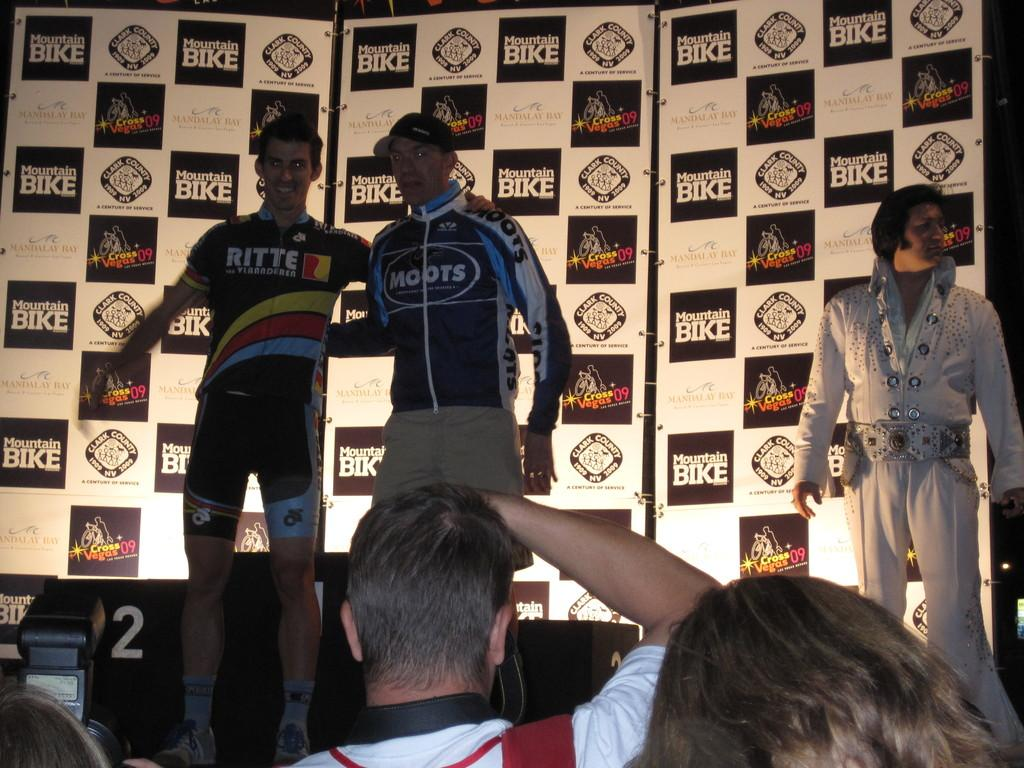<image>
Give a short and clear explanation of the subsequent image. Man standing in front of a sign which says "Moutain Bike" on it. 